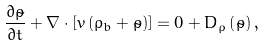<formula> <loc_0><loc_0><loc_500><loc_500>\frac { \partial \tilde { \rho } } { \partial t } + \nabla \cdot \left [ { v } \left ( \rho _ { b } + \tilde { \rho } \right ) \right ] = 0 + D _ { \rho } \left ( \tilde { \rho } \right ) ,</formula> 